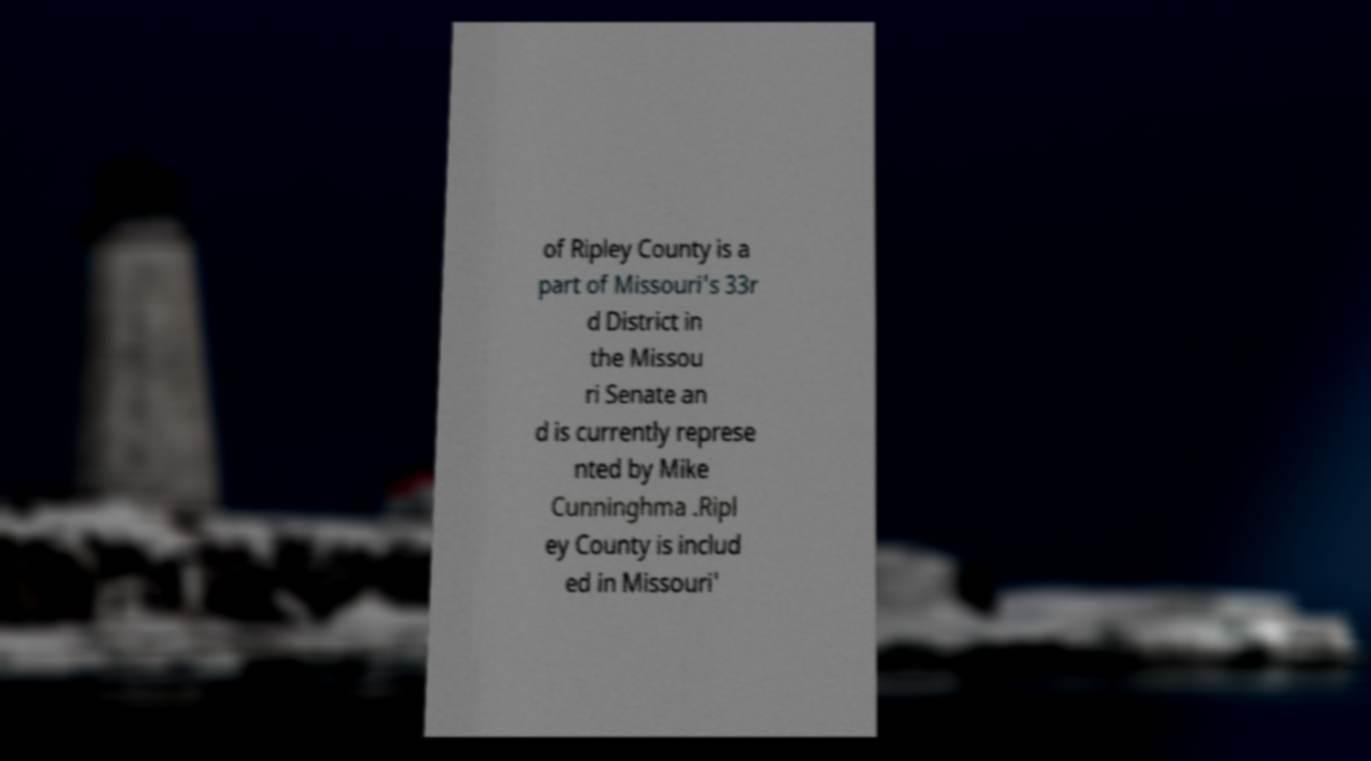Please identify and transcribe the text found in this image. of Ripley County is a part of Missouri's 33r d District in the Missou ri Senate an d is currently represe nted by Mike Cunninghma .Ripl ey County is includ ed in Missouri' 